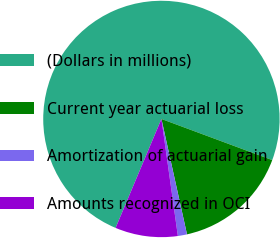<chart> <loc_0><loc_0><loc_500><loc_500><pie_chart><fcel>(Dollars in millions)<fcel>Current year actuarial loss<fcel>Amortization of actuarial gain<fcel>Amounts recognized in OCI<nl><fcel>74.32%<fcel>15.87%<fcel>1.25%<fcel>8.56%<nl></chart> 